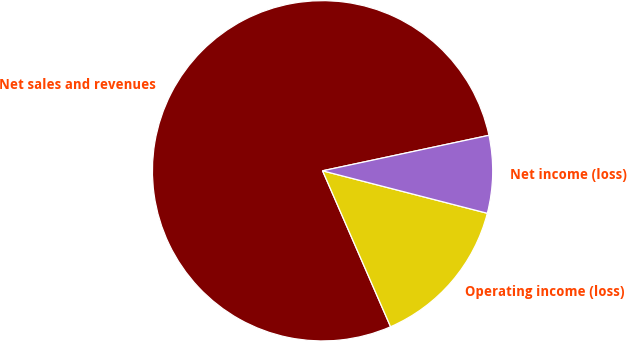Convert chart. <chart><loc_0><loc_0><loc_500><loc_500><pie_chart><fcel>Net sales and revenues<fcel>Operating income (loss)<fcel>Net income (loss)<nl><fcel>78.2%<fcel>14.44%<fcel>7.36%<nl></chart> 